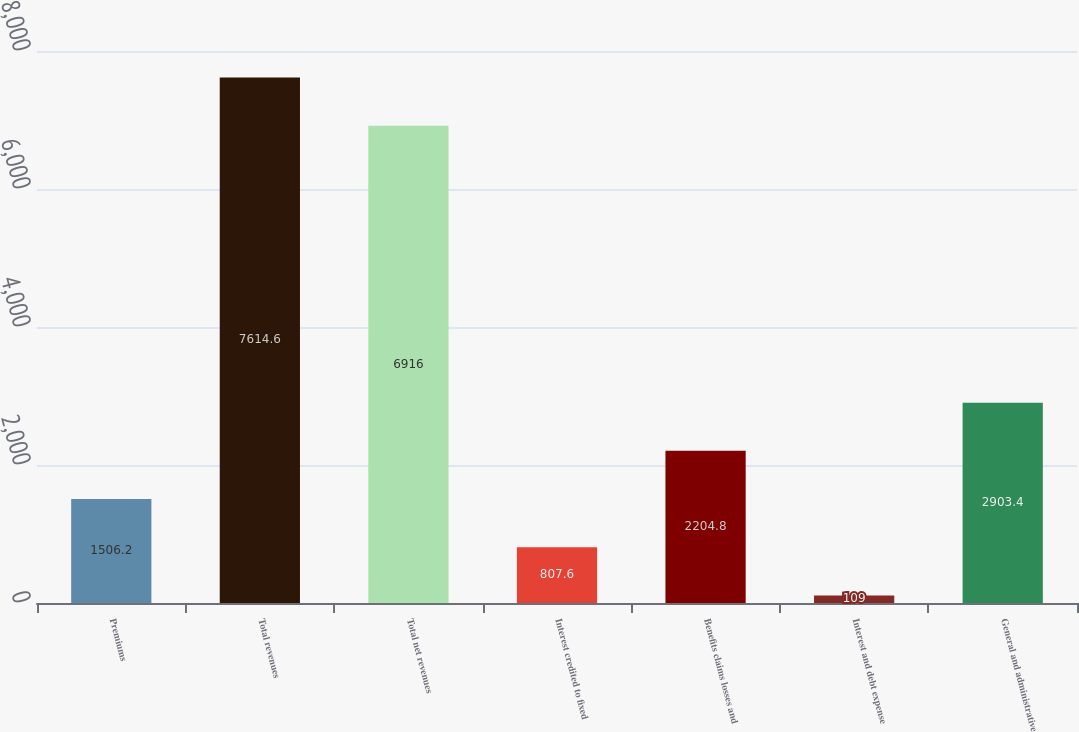Convert chart. <chart><loc_0><loc_0><loc_500><loc_500><bar_chart><fcel>Premiums<fcel>Total revenues<fcel>Total net revenues<fcel>Interest credited to fixed<fcel>Benefits claims losses and<fcel>Interest and debt expense<fcel>General and administrative<nl><fcel>1506.2<fcel>7614.6<fcel>6916<fcel>807.6<fcel>2204.8<fcel>109<fcel>2903.4<nl></chart> 